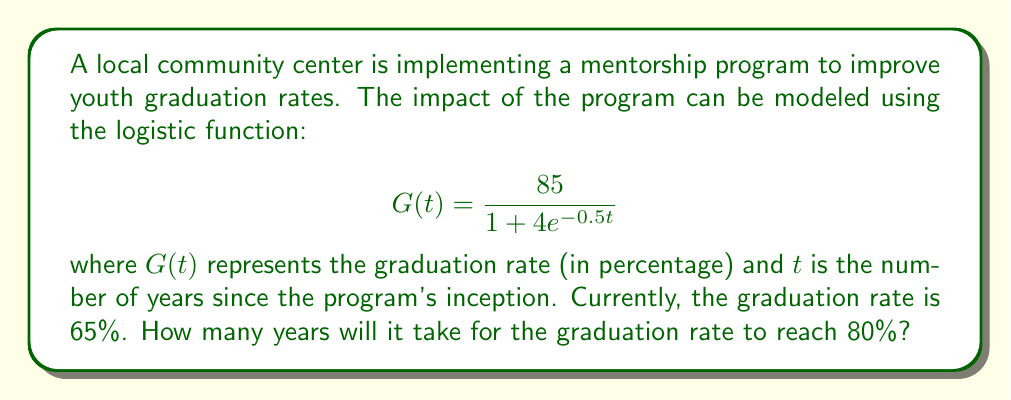What is the answer to this math problem? 1) We need to solve the equation:

   $$ 80 = \frac{85}{1 + 4e^{-0.5t}} $$

2) Multiply both sides by $(1 + 4e^{-0.5t})$:
   
   $$ 80(1 + 4e^{-0.5t}) = 85 $$

3) Distribute on the left side:
   
   $$ 80 + 320e^{-0.5t} = 85 $$

4) Subtract 80 from both sides:
   
   $$ 320e^{-0.5t} = 5 $$

5) Divide both sides by 320:
   
   $$ e^{-0.5t} = \frac{5}{320} = \frac{1}{64} $$

6) Take the natural log of both sides:
   
   $$ -0.5t = \ln(\frac{1}{64}) = -\ln(64) $$

7) Divide both sides by -0.5:
   
   $$ t = \frac{\ln(64)}{0.5} = 2\ln(64) \approx 8.32 $$

Therefore, it will take approximately 8.32 years for the graduation rate to reach 80%.
Answer: 8.32 years 